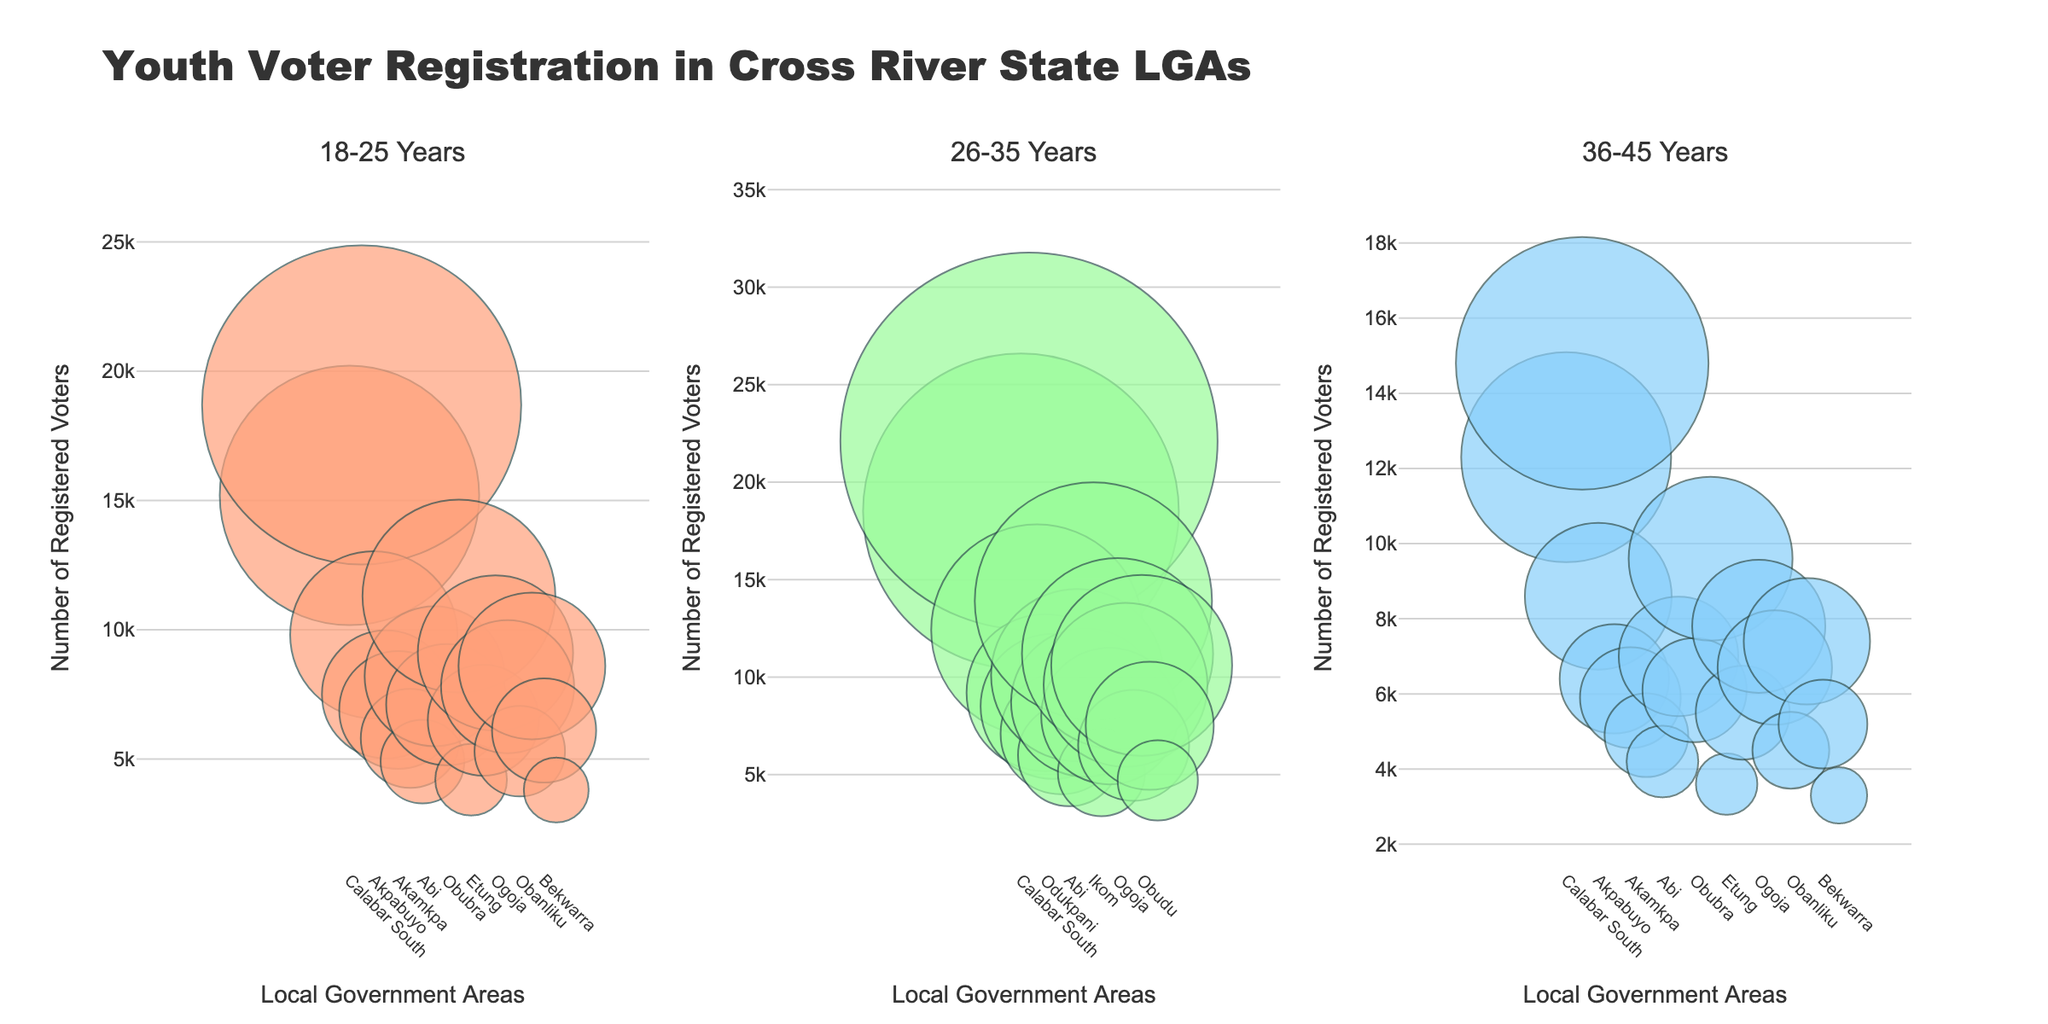What's the title of the figure? The title is usually located at the top of the figure. In this case, it reads 'Youth Voter Registration in Cross River State LGAs'.
Answer: Youth Voter Registration in Cross River State LGAs Which age group has the highest number of registered voters in Calabar Municipal? For Calabar Municipal, by observing the bubble sizes and their positions, you can see that the group '26-35 Years' has the largest bubble, indicating the highest number of registered voters.
Answer: 26-35 Years How many Local Government Areas (LGAs) are represented in the figure? Each subplot shows bubbles for the same number of LGAs, which can be counted. There are 18 data points (bubbles) representing 18 LGAs.
Answer: 18 In the '18-25 Years' category, which LGA has the smallest number of registered voters? In the '18-25 Years' subplot, the smallest bubble represents the LGA with the fewest registered voters. This is Bakassi.
Answer: Bakassi Compare the number of registered voters aged 36-45 in Calabar South and Akpabuyo; which one has more? By comparing the bubbles in the '36-45 Years' subplot, you can see that the bubble for Calabar South is larger than the one for Akpabuyo, indicating more registered voters.
Answer: Calabar South What's the total number of youth registered voters aged 26-35 across all LGAs? Add up the number of registered voters in the '26-35 Years' category from each LGA: 18500 + 22100 + 12400 + 9200 + 8500 + 7100 + 6000 + 10100 + 8700 + 13900 + 5100 + 8000 + 11200 + 9600 + 6500 + 10600 + 7500 + 4700 = 176200.
Answer: 176200 Which age group, on average, has the highest voter registration rate across all LGAs? Calculate the total registered voters for each age group across all LGAs and then divide by the number of LGAs (18). The group with the highest average is the one with the highest sum.
- 18-25: (15200+18700+9800+7500+6900+5800+4900+8200+7100+11300+4200+6500+9100+7800+5300+8600+6100+3800) = 164700; average = 164700 / 18 = 9150
- 26-35: (18500+22100+12400+9200+8500+7100+6000+10100+8700+13900+5100+8000+11200+9600+6500+10600+7500+4700) = 176200; average = 176200 / 18 = 9788.89
- 36-45: (12300+14800+8600+6400+5900+4900+4200+7000+6100+9600+3600+5500+7800+6700+4500+7400+5200+3300) = 120200; average = 120200 / 18 = 6688.89
The age group '26-35 Years' has the highest average.
Answer: 26-35 Years In Boki, what is the combined number of registered voters for all age groups shown (18-45)? Sum the registered voters for each of the three age groups for Boki: 6500 (18-25) + 8000 (26-35) + 5500 (36-45) = 20000.
Answer: 20000 Which LGA shows the most balanced registration numbers across the three age groups (18-25, 26-35, 36-45)? Look for the LGA whose bubbles are roughly the same size across all three subplots. Ogoja seems to have relatively balanced registration numbers with the bubbles having similar sizes.
Answer: Ogoja 